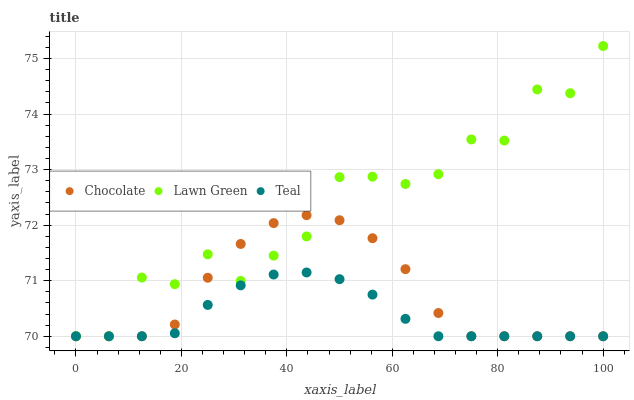Does Teal have the minimum area under the curve?
Answer yes or no. Yes. Does Lawn Green have the maximum area under the curve?
Answer yes or no. Yes. Does Chocolate have the minimum area under the curve?
Answer yes or no. No. Does Chocolate have the maximum area under the curve?
Answer yes or no. No. Is Teal the smoothest?
Answer yes or no. Yes. Is Lawn Green the roughest?
Answer yes or no. Yes. Is Chocolate the smoothest?
Answer yes or no. No. Is Chocolate the roughest?
Answer yes or no. No. Does Lawn Green have the lowest value?
Answer yes or no. Yes. Does Lawn Green have the highest value?
Answer yes or no. Yes. Does Chocolate have the highest value?
Answer yes or no. No. Does Teal intersect Lawn Green?
Answer yes or no. Yes. Is Teal less than Lawn Green?
Answer yes or no. No. Is Teal greater than Lawn Green?
Answer yes or no. No. 